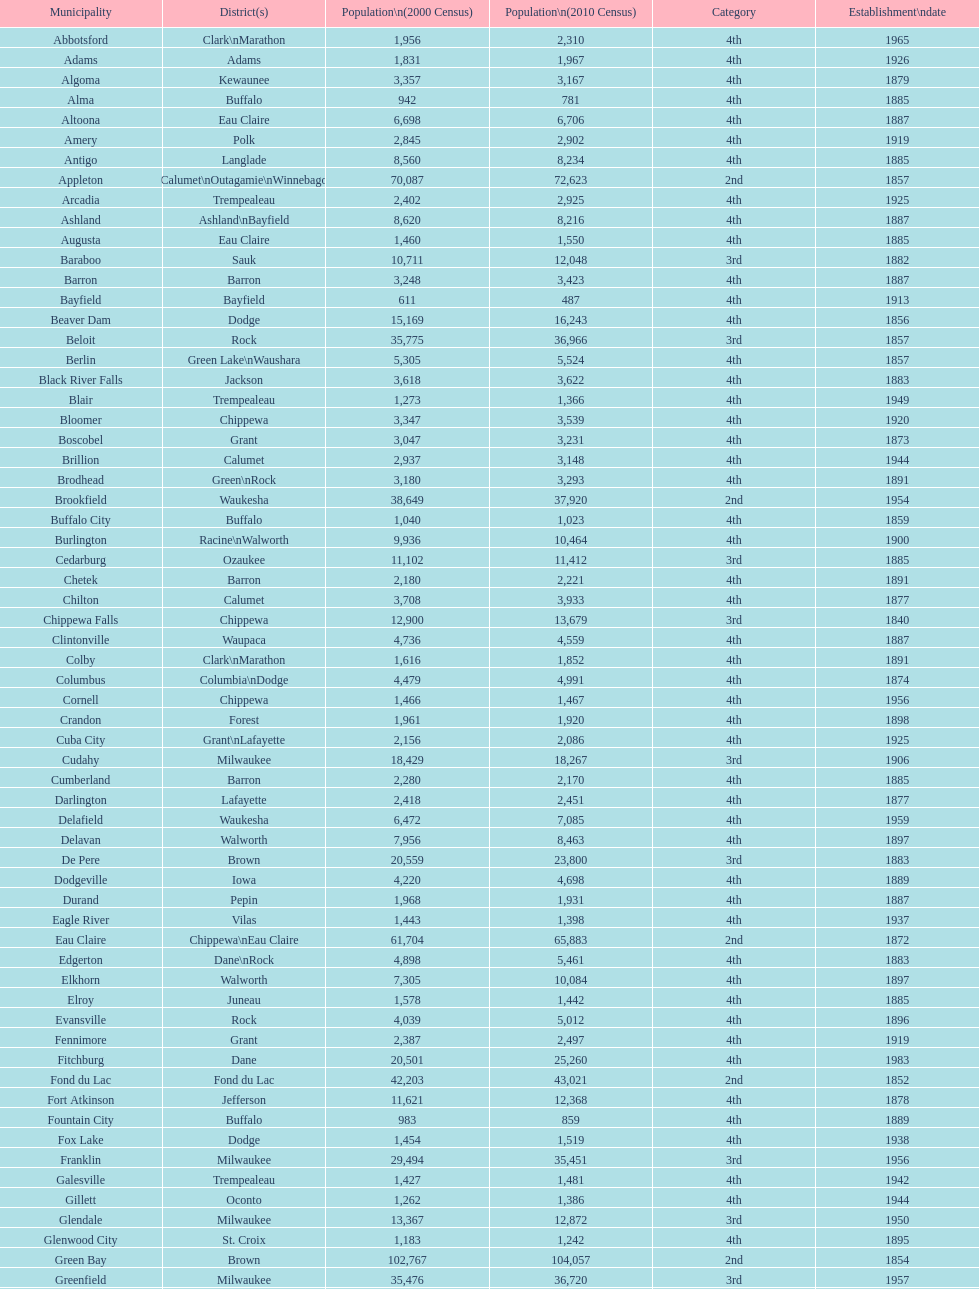Which city in wisconsin is the most populous, based on the 2010 census? Milwaukee. 